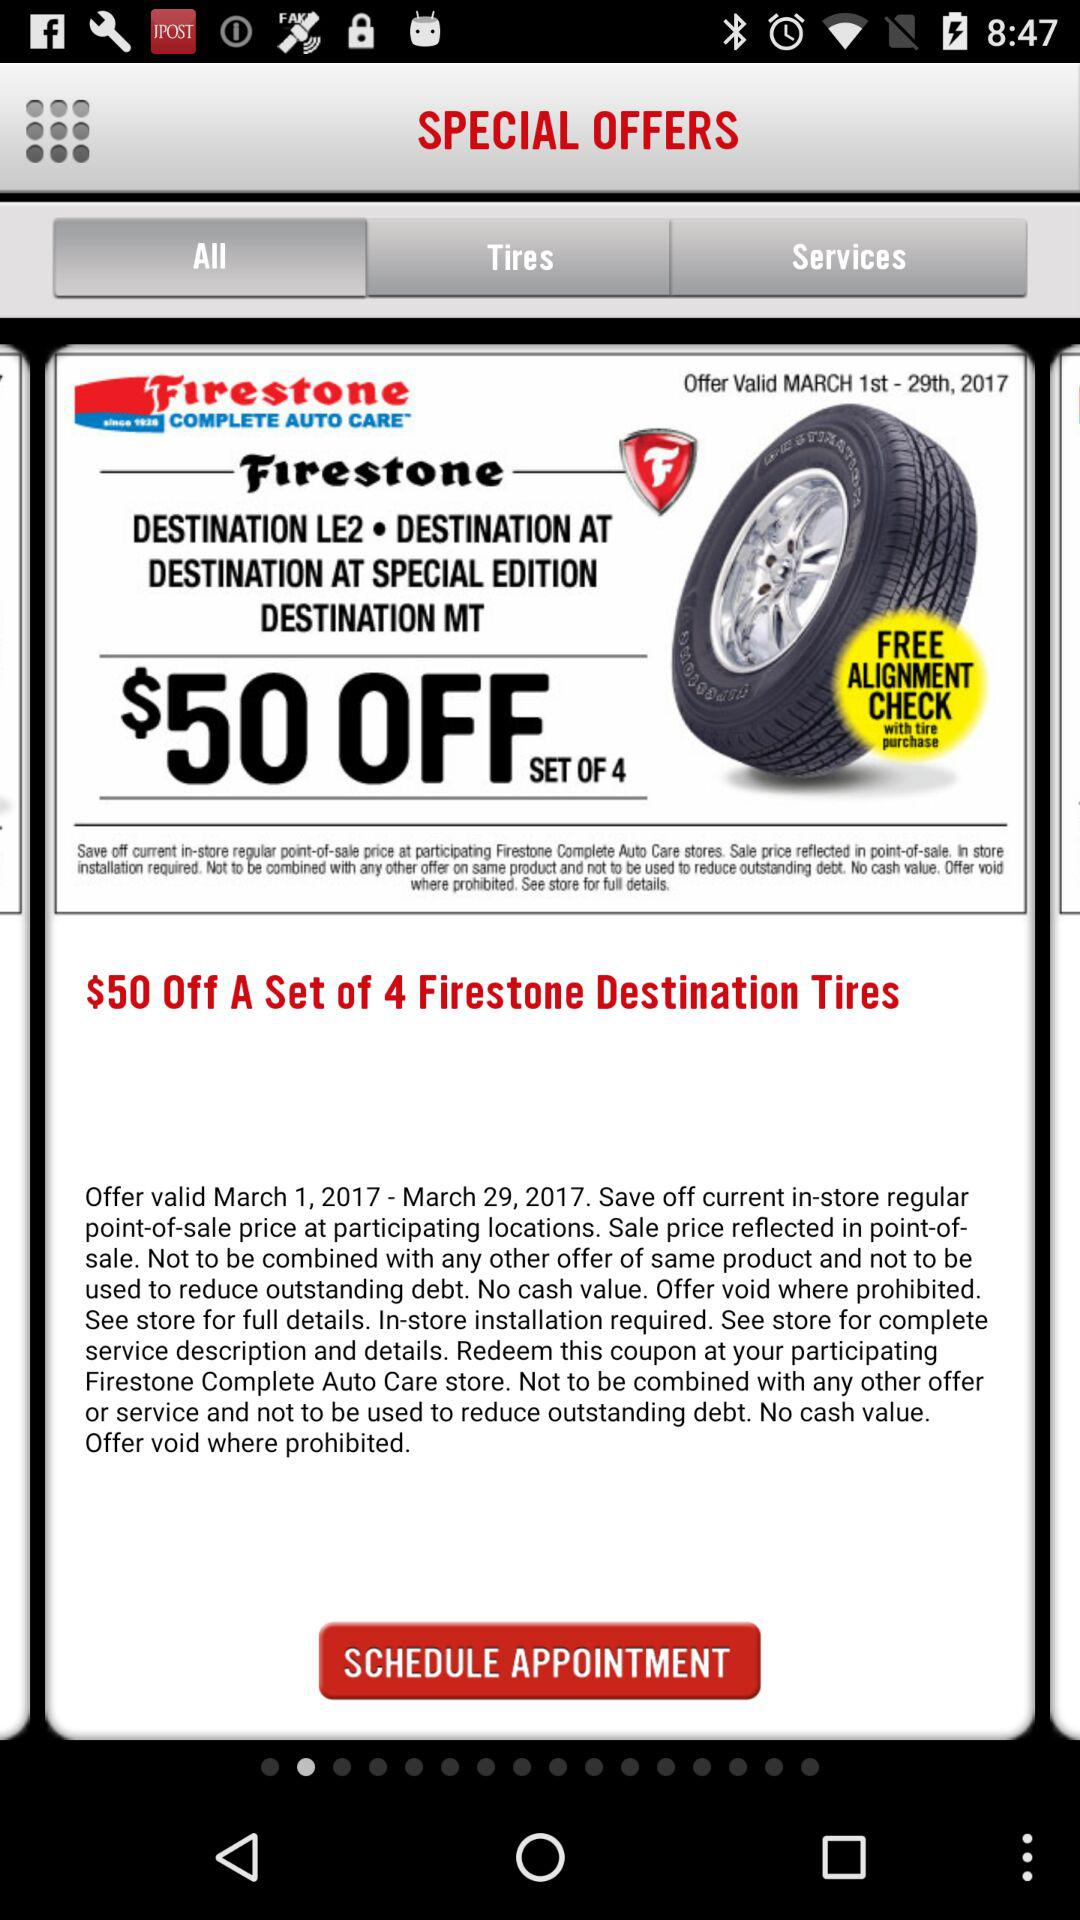When is the next available appointment?
When the provided information is insufficient, respond with <no answer>. <no answer> 